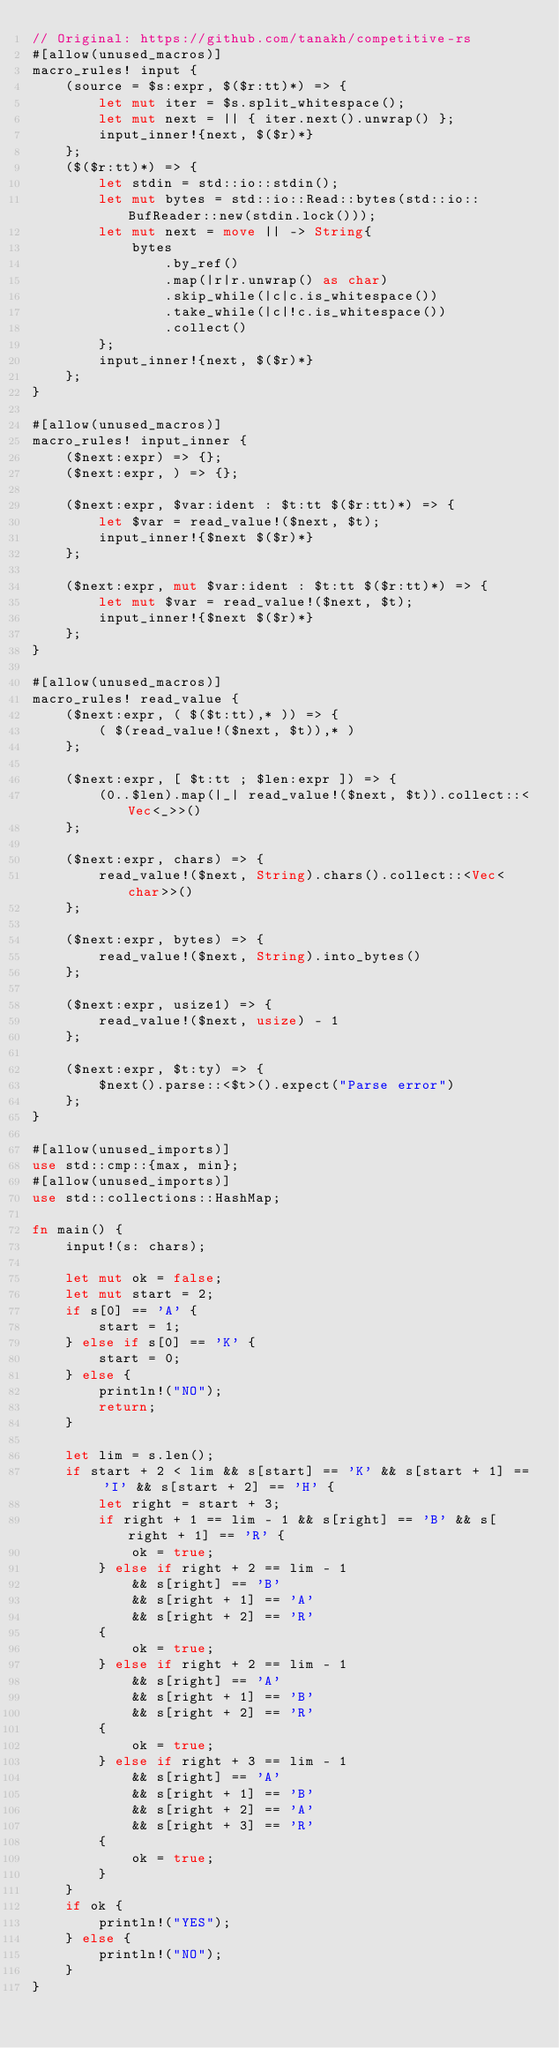<code> <loc_0><loc_0><loc_500><loc_500><_Rust_>// Original: https://github.com/tanakh/competitive-rs
#[allow(unused_macros)]
macro_rules! input {
    (source = $s:expr, $($r:tt)*) => {
        let mut iter = $s.split_whitespace();
        let mut next = || { iter.next().unwrap() };
        input_inner!{next, $($r)*}
    };
    ($($r:tt)*) => {
        let stdin = std::io::stdin();
        let mut bytes = std::io::Read::bytes(std::io::BufReader::new(stdin.lock()));
        let mut next = move || -> String{
            bytes
                .by_ref()
                .map(|r|r.unwrap() as char)
                .skip_while(|c|c.is_whitespace())
                .take_while(|c|!c.is_whitespace())
                .collect()
        };
        input_inner!{next, $($r)*}
    };
}

#[allow(unused_macros)]
macro_rules! input_inner {
    ($next:expr) => {};
    ($next:expr, ) => {};

    ($next:expr, $var:ident : $t:tt $($r:tt)*) => {
        let $var = read_value!($next, $t);
        input_inner!{$next $($r)*}
    };

    ($next:expr, mut $var:ident : $t:tt $($r:tt)*) => {
        let mut $var = read_value!($next, $t);
        input_inner!{$next $($r)*}
    };
}

#[allow(unused_macros)]
macro_rules! read_value {
    ($next:expr, ( $($t:tt),* )) => {
        ( $(read_value!($next, $t)),* )
    };

    ($next:expr, [ $t:tt ; $len:expr ]) => {
        (0..$len).map(|_| read_value!($next, $t)).collect::<Vec<_>>()
    };

    ($next:expr, chars) => {
        read_value!($next, String).chars().collect::<Vec<char>>()
    };

    ($next:expr, bytes) => {
        read_value!($next, String).into_bytes()
    };

    ($next:expr, usize1) => {
        read_value!($next, usize) - 1
    };

    ($next:expr, $t:ty) => {
        $next().parse::<$t>().expect("Parse error")
    };
}

#[allow(unused_imports)]
use std::cmp::{max, min};
#[allow(unused_imports)]
use std::collections::HashMap;

fn main() {
    input!(s: chars);

    let mut ok = false;
    let mut start = 2;
    if s[0] == 'A' {
        start = 1;
    } else if s[0] == 'K' {
        start = 0;
    } else {
        println!("NO");
        return;
    }

    let lim = s.len();
    if start + 2 < lim && s[start] == 'K' && s[start + 1] == 'I' && s[start + 2] == 'H' {
        let right = start + 3;
        if right + 1 == lim - 1 && s[right] == 'B' && s[right + 1] == 'R' {
            ok = true;
        } else if right + 2 == lim - 1
            && s[right] == 'B'
            && s[right + 1] == 'A'
            && s[right + 2] == 'R'
        {
            ok = true;
        } else if right + 2 == lim - 1
            && s[right] == 'A'
            && s[right + 1] == 'B'
            && s[right + 2] == 'R'
        {
            ok = true;
        } else if right + 3 == lim - 1
            && s[right] == 'A'
            && s[right + 1] == 'B'
            && s[right + 2] == 'A'
            && s[right + 3] == 'R'
        {
            ok = true;
        }
    }
    if ok {
        println!("YES");
    } else {
        println!("NO");
    }
}
</code> 